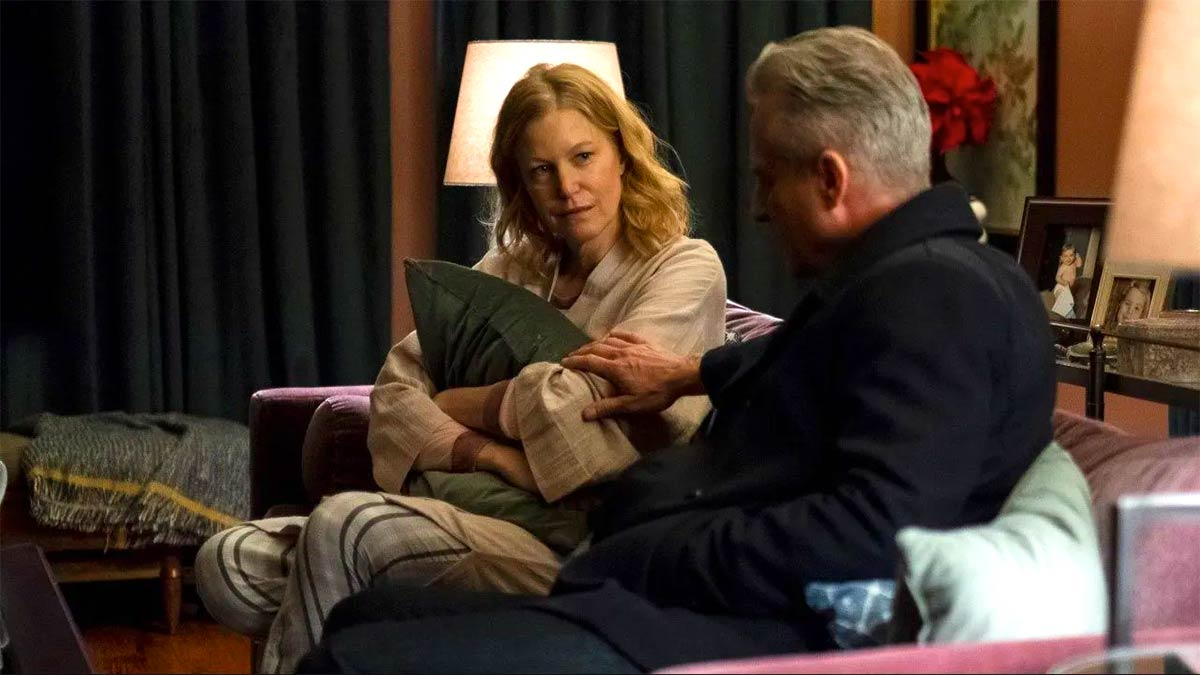How does the living room setting add to the overall atmosphere depicted in the image? The living room setting significantly enhances the overall atmosphere of the image by providing a sense of warmth and intimacy. The soft lighting, with a prominent table lamp casting a cozy glow, makes the space feel inviting. The comfortable seating arrangement, with plush couches and pillows, adds to the sense of homeliness and relaxation. Personal touches, such as family photos on the mantle above the fireplace, a blanket draped over one side of the couch, and flowers in a vase, contribute to creating a lived-in, personal space. These elements together evoke a feeling of safety and familiarity, making it an ideal backdrop for a heartfelt and deep conversation between the two characters. What if the scene took place outdoors at night? If this scene took place outdoors at night, the mood and atmosphere would shift considerably. An outdoor setting would introduce elements like cool night air and potentially ambient sounds such as rustling leaves, crickets, or distant city noises. The lighting would be darker, relying on street lamps or moonlight, creating a more dramatic or possibly somber tone. The sense of privacy might be heightened as the characters converse under the open sky, adding to the depth and gravity of their discussion. The warmth and comfort of an indoor setting would be replaced by the raw, open feeling of the outdoors, possibly making their conversation feel more exposed and urgent. 